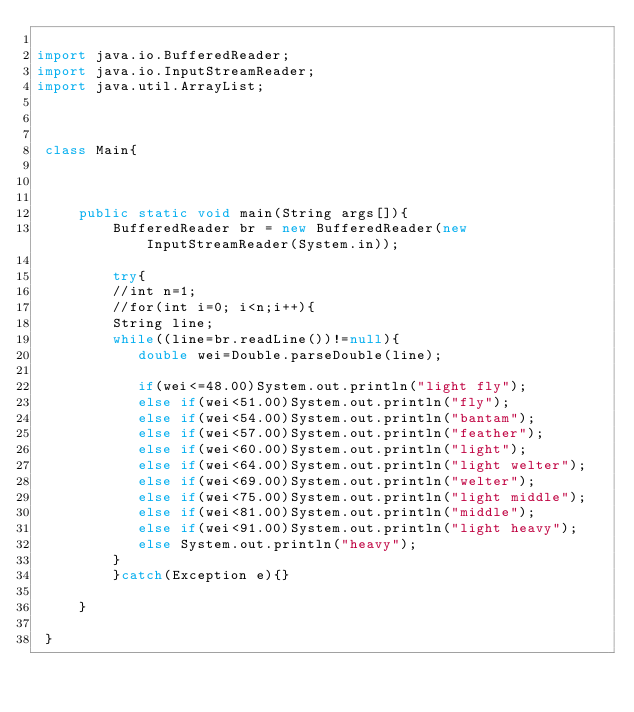Convert code to text. <code><loc_0><loc_0><loc_500><loc_500><_Java_>
import java.io.BufferedReader;
import java.io.InputStreamReader;
import java.util.ArrayList;



 class Main{
     
    
    
     public static void main(String args[]){
         BufferedReader br = new BufferedReader(new InputStreamReader(System.in));
        
         try{
         //int n=1;
         //for(int i=0; i<n;i++){
         String line;
         while((line=br.readLine())!=null){
            double wei=Double.parseDouble(line);
             
            if(wei<=48.00)System.out.println("light fly");
            else if(wei<51.00)System.out.println("fly");
            else if(wei<54.00)System.out.println("bantam");
            else if(wei<57.00)System.out.println("feather");
            else if(wei<60.00)System.out.println("light");
            else if(wei<64.00)System.out.println("light welter");
            else if(wei<69.00)System.out.println("welter");
            else if(wei<75.00)System.out.println("light middle");
            else if(wei<81.00)System.out.println("middle");
            else if(wei<91.00)System.out.println("light heavy");
            else System.out.println("heavy");
         }
         }catch(Exception e){}
         
     }
     
 }</code> 